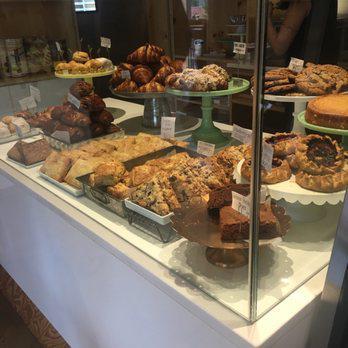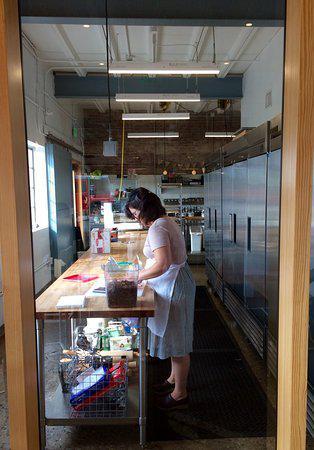The first image is the image on the left, the second image is the image on the right. Considering the images on both sides, is "In at least one image you can see at least 5 adults sitting in  white and light brown chair with at least 5 visible  dropped white lights." valid? Answer yes or no. No. The first image is the image on the left, the second image is the image on the right. Analyze the images presented: Is the assertion "White lamps hang down over tables in a bakery in one of the images." valid? Answer yes or no. No. 